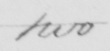Transcribe the text shown in this historical manuscript line. two 